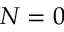Convert formula to latex. <formula><loc_0><loc_0><loc_500><loc_500>N = 0</formula> 